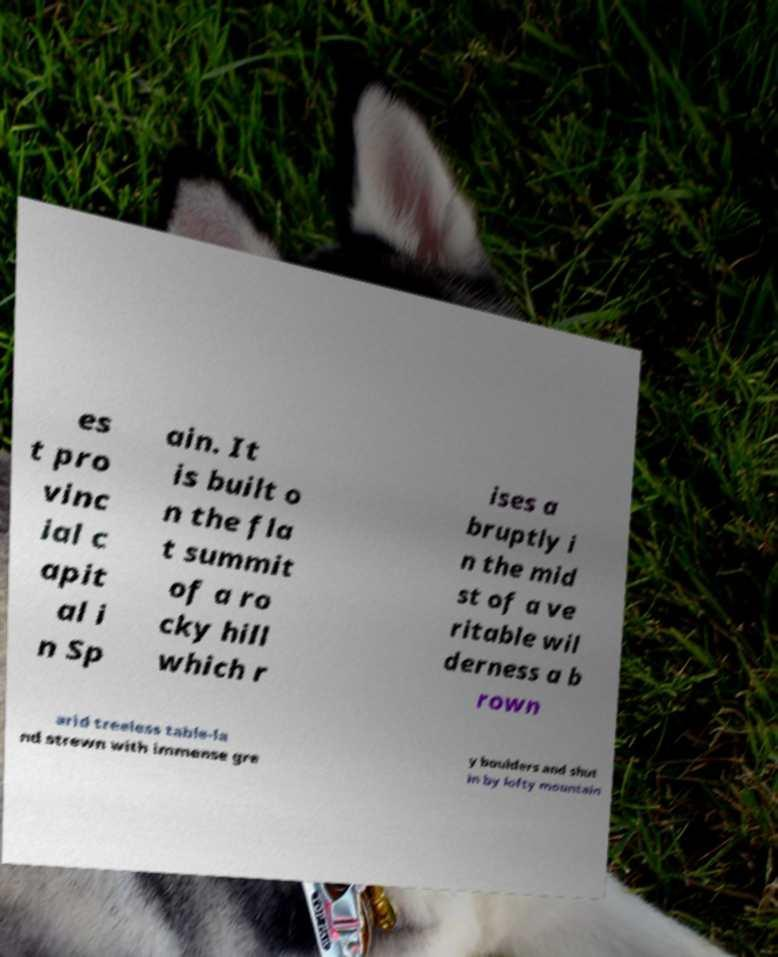What messages or text are displayed in this image? I need them in a readable, typed format. es t pro vinc ial c apit al i n Sp ain. It is built o n the fla t summit of a ro cky hill which r ises a bruptly i n the mid st of a ve ritable wil derness a b rown arid treeless table-la nd strewn with immense gre y boulders and shut in by lofty mountain 